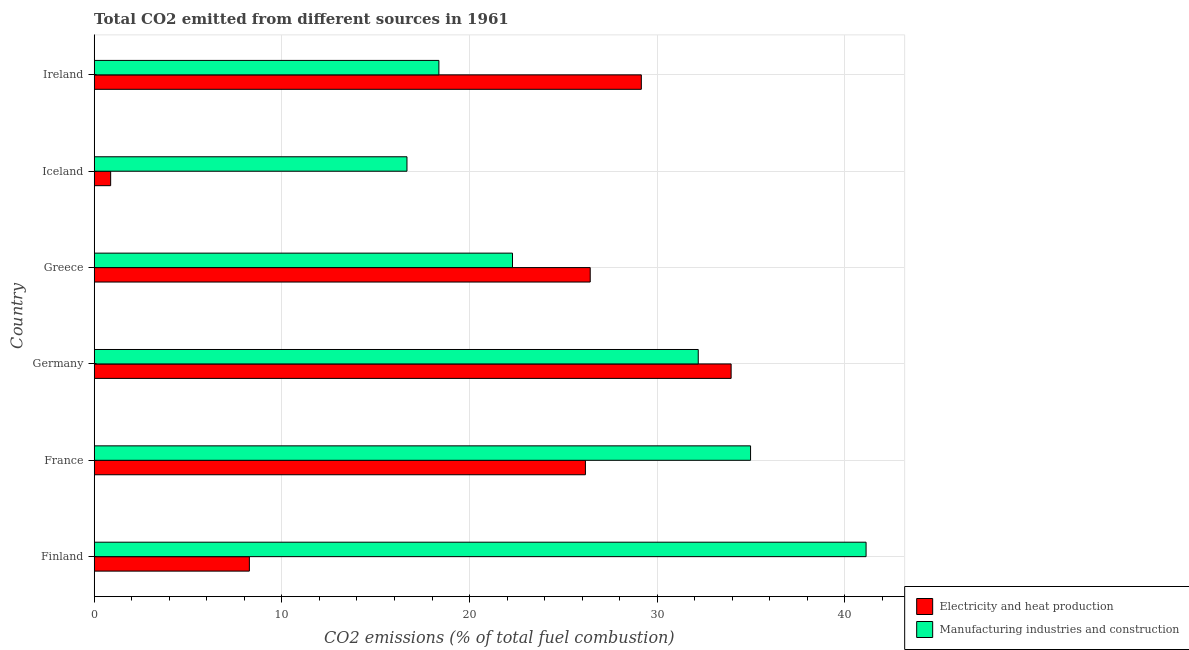Are the number of bars per tick equal to the number of legend labels?
Offer a very short reply. Yes. Are the number of bars on each tick of the Y-axis equal?
Keep it short and to the point. Yes. How many bars are there on the 2nd tick from the bottom?
Your answer should be very brief. 2. What is the label of the 6th group of bars from the top?
Keep it short and to the point. Finland. What is the co2 emissions due to electricity and heat production in Finland?
Keep it short and to the point. 8.27. Across all countries, what is the maximum co2 emissions due to manufacturing industries?
Provide a short and direct response. 41.13. Across all countries, what is the minimum co2 emissions due to manufacturing industries?
Provide a short and direct response. 16.67. What is the total co2 emissions due to electricity and heat production in the graph?
Offer a very short reply. 124.85. What is the difference between the co2 emissions due to electricity and heat production in Germany and that in Iceland?
Ensure brevity in your answer.  33.06. What is the difference between the co2 emissions due to manufacturing industries in Greece and the co2 emissions due to electricity and heat production in France?
Provide a short and direct response. -3.89. What is the average co2 emissions due to electricity and heat production per country?
Offer a very short reply. 20.81. What is the difference between the co2 emissions due to electricity and heat production and co2 emissions due to manufacturing industries in Greece?
Offer a terse response. 4.14. In how many countries, is the co2 emissions due to electricity and heat production greater than 20 %?
Offer a terse response. 4. What is the ratio of the co2 emissions due to manufacturing industries in Finland to that in France?
Your answer should be very brief. 1.18. What is the difference between the highest and the second highest co2 emissions due to electricity and heat production?
Your response must be concise. 4.79. What is the difference between the highest and the lowest co2 emissions due to manufacturing industries?
Your answer should be very brief. 24.46. In how many countries, is the co2 emissions due to electricity and heat production greater than the average co2 emissions due to electricity and heat production taken over all countries?
Make the answer very short. 4. Is the sum of the co2 emissions due to manufacturing industries in Greece and Ireland greater than the maximum co2 emissions due to electricity and heat production across all countries?
Your answer should be compact. Yes. What does the 2nd bar from the top in Finland represents?
Your answer should be compact. Electricity and heat production. What does the 1st bar from the bottom in France represents?
Your response must be concise. Electricity and heat production. How many bars are there?
Your response must be concise. 12. How many countries are there in the graph?
Your answer should be compact. 6. What is the difference between two consecutive major ticks on the X-axis?
Ensure brevity in your answer.  10. Does the graph contain any zero values?
Your answer should be very brief. No. Where does the legend appear in the graph?
Give a very brief answer. Bottom right. How are the legend labels stacked?
Offer a very short reply. Vertical. What is the title of the graph?
Your answer should be very brief. Total CO2 emitted from different sources in 1961. Does "Manufacturing industries and construction" appear as one of the legend labels in the graph?
Offer a terse response. Yes. What is the label or title of the X-axis?
Provide a short and direct response. CO2 emissions (% of total fuel combustion). What is the label or title of the Y-axis?
Provide a short and direct response. Country. What is the CO2 emissions (% of total fuel combustion) of Electricity and heat production in Finland?
Provide a short and direct response. 8.27. What is the CO2 emissions (% of total fuel combustion) of Manufacturing industries and construction in Finland?
Provide a succinct answer. 41.13. What is the CO2 emissions (% of total fuel combustion) of Electricity and heat production in France?
Give a very brief answer. 26.18. What is the CO2 emissions (% of total fuel combustion) of Manufacturing industries and construction in France?
Your response must be concise. 34.98. What is the CO2 emissions (% of total fuel combustion) of Electricity and heat production in Germany?
Keep it short and to the point. 33.94. What is the CO2 emissions (% of total fuel combustion) of Manufacturing industries and construction in Germany?
Your answer should be very brief. 32.19. What is the CO2 emissions (% of total fuel combustion) of Electricity and heat production in Greece?
Provide a short and direct response. 26.43. What is the CO2 emissions (% of total fuel combustion) of Manufacturing industries and construction in Greece?
Give a very brief answer. 22.29. What is the CO2 emissions (% of total fuel combustion) of Electricity and heat production in Iceland?
Make the answer very short. 0.88. What is the CO2 emissions (% of total fuel combustion) of Manufacturing industries and construction in Iceland?
Offer a terse response. 16.67. What is the CO2 emissions (% of total fuel combustion) of Electricity and heat production in Ireland?
Offer a very short reply. 29.15. What is the CO2 emissions (% of total fuel combustion) in Manufacturing industries and construction in Ireland?
Make the answer very short. 18.37. Across all countries, what is the maximum CO2 emissions (% of total fuel combustion) in Electricity and heat production?
Keep it short and to the point. 33.94. Across all countries, what is the maximum CO2 emissions (% of total fuel combustion) in Manufacturing industries and construction?
Make the answer very short. 41.13. Across all countries, what is the minimum CO2 emissions (% of total fuel combustion) of Electricity and heat production?
Give a very brief answer. 0.88. Across all countries, what is the minimum CO2 emissions (% of total fuel combustion) in Manufacturing industries and construction?
Make the answer very short. 16.67. What is the total CO2 emissions (% of total fuel combustion) of Electricity and heat production in the graph?
Offer a very short reply. 124.85. What is the total CO2 emissions (% of total fuel combustion) in Manufacturing industries and construction in the graph?
Give a very brief answer. 165.62. What is the difference between the CO2 emissions (% of total fuel combustion) of Electricity and heat production in Finland and that in France?
Ensure brevity in your answer.  -17.91. What is the difference between the CO2 emissions (% of total fuel combustion) of Manufacturing industries and construction in Finland and that in France?
Make the answer very short. 6.16. What is the difference between the CO2 emissions (% of total fuel combustion) of Electricity and heat production in Finland and that in Germany?
Keep it short and to the point. -25.67. What is the difference between the CO2 emissions (% of total fuel combustion) in Manufacturing industries and construction in Finland and that in Germany?
Offer a terse response. 8.94. What is the difference between the CO2 emissions (% of total fuel combustion) of Electricity and heat production in Finland and that in Greece?
Provide a short and direct response. -18.16. What is the difference between the CO2 emissions (% of total fuel combustion) of Manufacturing industries and construction in Finland and that in Greece?
Give a very brief answer. 18.84. What is the difference between the CO2 emissions (% of total fuel combustion) of Electricity and heat production in Finland and that in Iceland?
Your response must be concise. 7.39. What is the difference between the CO2 emissions (% of total fuel combustion) of Manufacturing industries and construction in Finland and that in Iceland?
Make the answer very short. 24.46. What is the difference between the CO2 emissions (% of total fuel combustion) of Electricity and heat production in Finland and that in Ireland?
Make the answer very short. -20.89. What is the difference between the CO2 emissions (% of total fuel combustion) of Manufacturing industries and construction in Finland and that in Ireland?
Ensure brevity in your answer.  22.76. What is the difference between the CO2 emissions (% of total fuel combustion) of Electricity and heat production in France and that in Germany?
Provide a succinct answer. -7.76. What is the difference between the CO2 emissions (% of total fuel combustion) of Manufacturing industries and construction in France and that in Germany?
Ensure brevity in your answer.  2.79. What is the difference between the CO2 emissions (% of total fuel combustion) of Electricity and heat production in France and that in Greece?
Your answer should be very brief. -0.26. What is the difference between the CO2 emissions (% of total fuel combustion) of Manufacturing industries and construction in France and that in Greece?
Your answer should be very brief. 12.69. What is the difference between the CO2 emissions (% of total fuel combustion) in Electricity and heat production in France and that in Iceland?
Offer a terse response. 25.3. What is the difference between the CO2 emissions (% of total fuel combustion) of Manufacturing industries and construction in France and that in Iceland?
Your response must be concise. 18.31. What is the difference between the CO2 emissions (% of total fuel combustion) in Electricity and heat production in France and that in Ireland?
Provide a succinct answer. -2.98. What is the difference between the CO2 emissions (% of total fuel combustion) of Manufacturing industries and construction in France and that in Ireland?
Offer a terse response. 16.61. What is the difference between the CO2 emissions (% of total fuel combustion) in Electricity and heat production in Germany and that in Greece?
Your answer should be very brief. 7.51. What is the difference between the CO2 emissions (% of total fuel combustion) of Manufacturing industries and construction in Germany and that in Greece?
Offer a terse response. 9.9. What is the difference between the CO2 emissions (% of total fuel combustion) in Electricity and heat production in Germany and that in Iceland?
Provide a short and direct response. 33.06. What is the difference between the CO2 emissions (% of total fuel combustion) in Manufacturing industries and construction in Germany and that in Iceland?
Your answer should be very brief. 15.52. What is the difference between the CO2 emissions (% of total fuel combustion) of Electricity and heat production in Germany and that in Ireland?
Offer a terse response. 4.79. What is the difference between the CO2 emissions (% of total fuel combustion) of Manufacturing industries and construction in Germany and that in Ireland?
Give a very brief answer. 13.82. What is the difference between the CO2 emissions (% of total fuel combustion) of Electricity and heat production in Greece and that in Iceland?
Your answer should be very brief. 25.55. What is the difference between the CO2 emissions (% of total fuel combustion) of Manufacturing industries and construction in Greece and that in Iceland?
Your response must be concise. 5.62. What is the difference between the CO2 emissions (% of total fuel combustion) of Electricity and heat production in Greece and that in Ireland?
Offer a terse response. -2.72. What is the difference between the CO2 emissions (% of total fuel combustion) in Manufacturing industries and construction in Greece and that in Ireland?
Ensure brevity in your answer.  3.92. What is the difference between the CO2 emissions (% of total fuel combustion) in Electricity and heat production in Iceland and that in Ireland?
Your response must be concise. -28.28. What is the difference between the CO2 emissions (% of total fuel combustion) in Manufacturing industries and construction in Iceland and that in Ireland?
Your response must be concise. -1.7. What is the difference between the CO2 emissions (% of total fuel combustion) in Electricity and heat production in Finland and the CO2 emissions (% of total fuel combustion) in Manufacturing industries and construction in France?
Offer a very short reply. -26.71. What is the difference between the CO2 emissions (% of total fuel combustion) in Electricity and heat production in Finland and the CO2 emissions (% of total fuel combustion) in Manufacturing industries and construction in Germany?
Provide a short and direct response. -23.92. What is the difference between the CO2 emissions (% of total fuel combustion) of Electricity and heat production in Finland and the CO2 emissions (% of total fuel combustion) of Manufacturing industries and construction in Greece?
Ensure brevity in your answer.  -14.02. What is the difference between the CO2 emissions (% of total fuel combustion) of Electricity and heat production in Finland and the CO2 emissions (% of total fuel combustion) of Manufacturing industries and construction in Iceland?
Your answer should be compact. -8.4. What is the difference between the CO2 emissions (% of total fuel combustion) of Electricity and heat production in Finland and the CO2 emissions (% of total fuel combustion) of Manufacturing industries and construction in Ireland?
Make the answer very short. -10.1. What is the difference between the CO2 emissions (% of total fuel combustion) of Electricity and heat production in France and the CO2 emissions (% of total fuel combustion) of Manufacturing industries and construction in Germany?
Give a very brief answer. -6.01. What is the difference between the CO2 emissions (% of total fuel combustion) of Electricity and heat production in France and the CO2 emissions (% of total fuel combustion) of Manufacturing industries and construction in Greece?
Provide a succinct answer. 3.89. What is the difference between the CO2 emissions (% of total fuel combustion) in Electricity and heat production in France and the CO2 emissions (% of total fuel combustion) in Manufacturing industries and construction in Iceland?
Provide a succinct answer. 9.51. What is the difference between the CO2 emissions (% of total fuel combustion) of Electricity and heat production in France and the CO2 emissions (% of total fuel combustion) of Manufacturing industries and construction in Ireland?
Keep it short and to the point. 7.81. What is the difference between the CO2 emissions (% of total fuel combustion) in Electricity and heat production in Germany and the CO2 emissions (% of total fuel combustion) in Manufacturing industries and construction in Greece?
Offer a very short reply. 11.65. What is the difference between the CO2 emissions (% of total fuel combustion) in Electricity and heat production in Germany and the CO2 emissions (% of total fuel combustion) in Manufacturing industries and construction in Iceland?
Give a very brief answer. 17.27. What is the difference between the CO2 emissions (% of total fuel combustion) in Electricity and heat production in Germany and the CO2 emissions (% of total fuel combustion) in Manufacturing industries and construction in Ireland?
Your answer should be very brief. 15.57. What is the difference between the CO2 emissions (% of total fuel combustion) of Electricity and heat production in Greece and the CO2 emissions (% of total fuel combustion) of Manufacturing industries and construction in Iceland?
Provide a short and direct response. 9.76. What is the difference between the CO2 emissions (% of total fuel combustion) in Electricity and heat production in Greece and the CO2 emissions (% of total fuel combustion) in Manufacturing industries and construction in Ireland?
Provide a short and direct response. 8.06. What is the difference between the CO2 emissions (% of total fuel combustion) in Electricity and heat production in Iceland and the CO2 emissions (% of total fuel combustion) in Manufacturing industries and construction in Ireland?
Your answer should be compact. -17.49. What is the average CO2 emissions (% of total fuel combustion) in Electricity and heat production per country?
Provide a succinct answer. 20.81. What is the average CO2 emissions (% of total fuel combustion) of Manufacturing industries and construction per country?
Provide a succinct answer. 27.6. What is the difference between the CO2 emissions (% of total fuel combustion) in Electricity and heat production and CO2 emissions (% of total fuel combustion) in Manufacturing industries and construction in Finland?
Your answer should be compact. -32.86. What is the difference between the CO2 emissions (% of total fuel combustion) of Electricity and heat production and CO2 emissions (% of total fuel combustion) of Manufacturing industries and construction in France?
Offer a terse response. -8.8. What is the difference between the CO2 emissions (% of total fuel combustion) in Electricity and heat production and CO2 emissions (% of total fuel combustion) in Manufacturing industries and construction in Germany?
Your response must be concise. 1.75. What is the difference between the CO2 emissions (% of total fuel combustion) of Electricity and heat production and CO2 emissions (% of total fuel combustion) of Manufacturing industries and construction in Greece?
Give a very brief answer. 4.14. What is the difference between the CO2 emissions (% of total fuel combustion) in Electricity and heat production and CO2 emissions (% of total fuel combustion) in Manufacturing industries and construction in Iceland?
Make the answer very short. -15.79. What is the difference between the CO2 emissions (% of total fuel combustion) in Electricity and heat production and CO2 emissions (% of total fuel combustion) in Manufacturing industries and construction in Ireland?
Offer a terse response. 10.79. What is the ratio of the CO2 emissions (% of total fuel combustion) in Electricity and heat production in Finland to that in France?
Provide a succinct answer. 0.32. What is the ratio of the CO2 emissions (% of total fuel combustion) of Manufacturing industries and construction in Finland to that in France?
Offer a terse response. 1.18. What is the ratio of the CO2 emissions (% of total fuel combustion) in Electricity and heat production in Finland to that in Germany?
Your answer should be very brief. 0.24. What is the ratio of the CO2 emissions (% of total fuel combustion) of Manufacturing industries and construction in Finland to that in Germany?
Your answer should be compact. 1.28. What is the ratio of the CO2 emissions (% of total fuel combustion) of Electricity and heat production in Finland to that in Greece?
Make the answer very short. 0.31. What is the ratio of the CO2 emissions (% of total fuel combustion) in Manufacturing industries and construction in Finland to that in Greece?
Your answer should be very brief. 1.85. What is the ratio of the CO2 emissions (% of total fuel combustion) in Electricity and heat production in Finland to that in Iceland?
Your answer should be compact. 9.43. What is the ratio of the CO2 emissions (% of total fuel combustion) of Manufacturing industries and construction in Finland to that in Iceland?
Make the answer very short. 2.47. What is the ratio of the CO2 emissions (% of total fuel combustion) of Electricity and heat production in Finland to that in Ireland?
Ensure brevity in your answer.  0.28. What is the ratio of the CO2 emissions (% of total fuel combustion) in Manufacturing industries and construction in Finland to that in Ireland?
Provide a succinct answer. 2.24. What is the ratio of the CO2 emissions (% of total fuel combustion) of Electricity and heat production in France to that in Germany?
Keep it short and to the point. 0.77. What is the ratio of the CO2 emissions (% of total fuel combustion) of Manufacturing industries and construction in France to that in Germany?
Ensure brevity in your answer.  1.09. What is the ratio of the CO2 emissions (% of total fuel combustion) in Electricity and heat production in France to that in Greece?
Your answer should be very brief. 0.99. What is the ratio of the CO2 emissions (% of total fuel combustion) of Manufacturing industries and construction in France to that in Greece?
Your answer should be compact. 1.57. What is the ratio of the CO2 emissions (% of total fuel combustion) in Electricity and heat production in France to that in Iceland?
Offer a terse response. 29.84. What is the ratio of the CO2 emissions (% of total fuel combustion) in Manufacturing industries and construction in France to that in Iceland?
Provide a succinct answer. 2.1. What is the ratio of the CO2 emissions (% of total fuel combustion) of Electricity and heat production in France to that in Ireland?
Give a very brief answer. 0.9. What is the ratio of the CO2 emissions (% of total fuel combustion) in Manufacturing industries and construction in France to that in Ireland?
Offer a very short reply. 1.9. What is the ratio of the CO2 emissions (% of total fuel combustion) of Electricity and heat production in Germany to that in Greece?
Offer a terse response. 1.28. What is the ratio of the CO2 emissions (% of total fuel combustion) of Manufacturing industries and construction in Germany to that in Greece?
Your answer should be compact. 1.44. What is the ratio of the CO2 emissions (% of total fuel combustion) of Electricity and heat production in Germany to that in Iceland?
Make the answer very short. 38.69. What is the ratio of the CO2 emissions (% of total fuel combustion) in Manufacturing industries and construction in Germany to that in Iceland?
Provide a short and direct response. 1.93. What is the ratio of the CO2 emissions (% of total fuel combustion) in Electricity and heat production in Germany to that in Ireland?
Provide a short and direct response. 1.16. What is the ratio of the CO2 emissions (% of total fuel combustion) in Manufacturing industries and construction in Germany to that in Ireland?
Provide a short and direct response. 1.75. What is the ratio of the CO2 emissions (% of total fuel combustion) of Electricity and heat production in Greece to that in Iceland?
Make the answer very short. 30.13. What is the ratio of the CO2 emissions (% of total fuel combustion) of Manufacturing industries and construction in Greece to that in Iceland?
Your response must be concise. 1.34. What is the ratio of the CO2 emissions (% of total fuel combustion) of Electricity and heat production in Greece to that in Ireland?
Provide a succinct answer. 0.91. What is the ratio of the CO2 emissions (% of total fuel combustion) of Manufacturing industries and construction in Greece to that in Ireland?
Offer a very short reply. 1.21. What is the ratio of the CO2 emissions (% of total fuel combustion) of Electricity and heat production in Iceland to that in Ireland?
Your answer should be very brief. 0.03. What is the ratio of the CO2 emissions (% of total fuel combustion) in Manufacturing industries and construction in Iceland to that in Ireland?
Keep it short and to the point. 0.91. What is the difference between the highest and the second highest CO2 emissions (% of total fuel combustion) in Electricity and heat production?
Make the answer very short. 4.79. What is the difference between the highest and the second highest CO2 emissions (% of total fuel combustion) in Manufacturing industries and construction?
Keep it short and to the point. 6.16. What is the difference between the highest and the lowest CO2 emissions (% of total fuel combustion) in Electricity and heat production?
Your answer should be compact. 33.06. What is the difference between the highest and the lowest CO2 emissions (% of total fuel combustion) of Manufacturing industries and construction?
Provide a short and direct response. 24.46. 